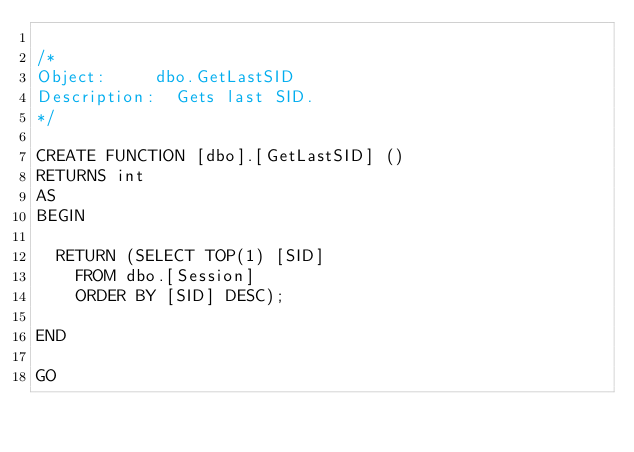<code> <loc_0><loc_0><loc_500><loc_500><_SQL_>
/*
Object:			dbo.GetLastSID
Description:	Gets last SID.
*/

CREATE FUNCTION [dbo].[GetLastSID] ()
RETURNS int
AS 
BEGIN 

	RETURN (SELECT TOP(1) [SID]
		FROM dbo.[Session]
		ORDER BY [SID] DESC);

END

GO
</code> 